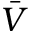Convert formula to latex. <formula><loc_0><loc_0><loc_500><loc_500>\bar { V }</formula> 